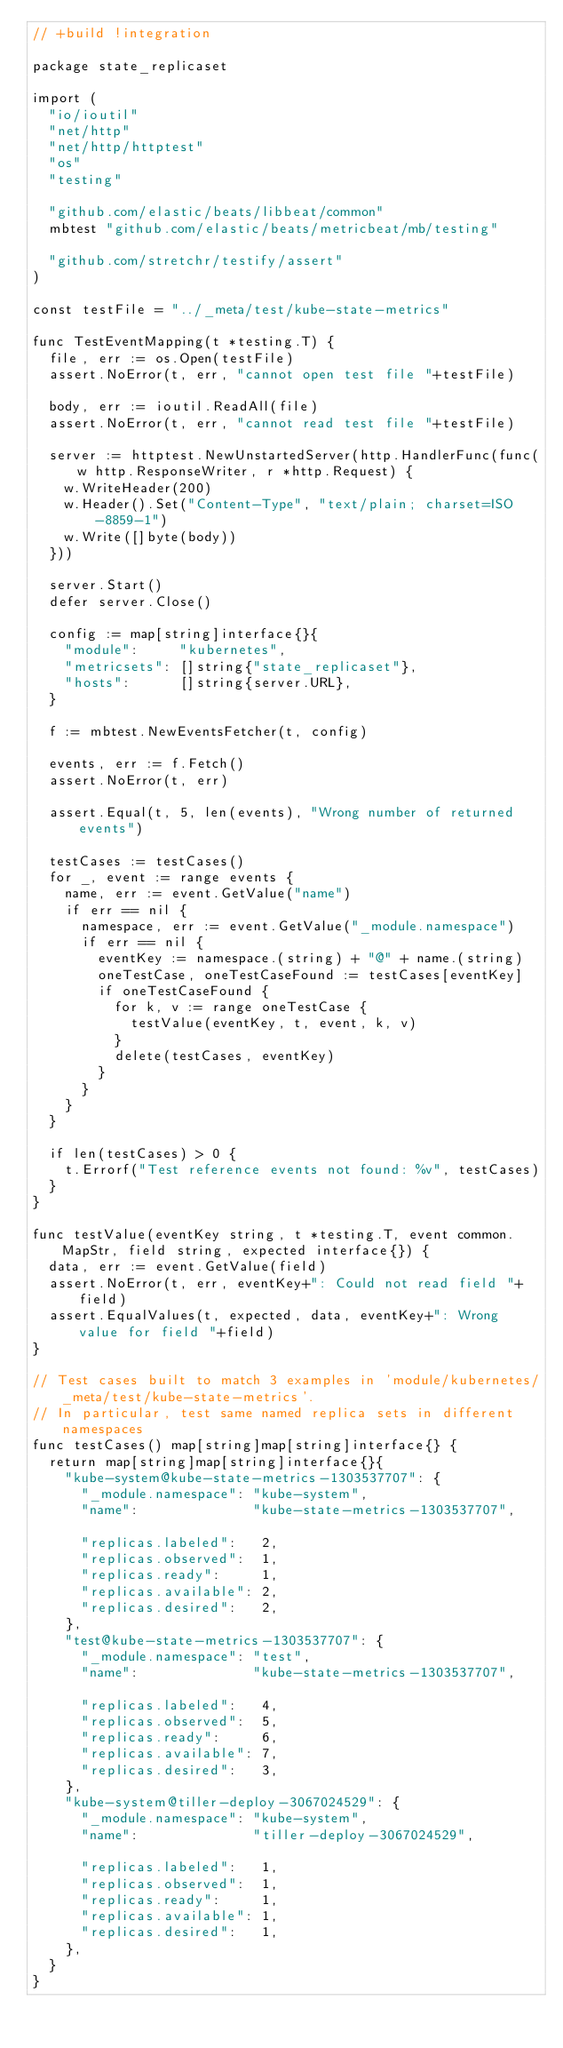Convert code to text. <code><loc_0><loc_0><loc_500><loc_500><_Go_>// +build !integration

package state_replicaset

import (
	"io/ioutil"
	"net/http"
	"net/http/httptest"
	"os"
	"testing"

	"github.com/elastic/beats/libbeat/common"
	mbtest "github.com/elastic/beats/metricbeat/mb/testing"

	"github.com/stretchr/testify/assert"
)

const testFile = "../_meta/test/kube-state-metrics"

func TestEventMapping(t *testing.T) {
	file, err := os.Open(testFile)
	assert.NoError(t, err, "cannot open test file "+testFile)

	body, err := ioutil.ReadAll(file)
	assert.NoError(t, err, "cannot read test file "+testFile)

	server := httptest.NewUnstartedServer(http.HandlerFunc(func(w http.ResponseWriter, r *http.Request) {
		w.WriteHeader(200)
		w.Header().Set("Content-Type", "text/plain; charset=ISO-8859-1")
		w.Write([]byte(body))
	}))

	server.Start()
	defer server.Close()

	config := map[string]interface{}{
		"module":     "kubernetes",
		"metricsets": []string{"state_replicaset"},
		"hosts":      []string{server.URL},
	}

	f := mbtest.NewEventsFetcher(t, config)

	events, err := f.Fetch()
	assert.NoError(t, err)

	assert.Equal(t, 5, len(events), "Wrong number of returned events")

	testCases := testCases()
	for _, event := range events {
		name, err := event.GetValue("name")
		if err == nil {
			namespace, err := event.GetValue("_module.namespace")
			if err == nil {
				eventKey := namespace.(string) + "@" + name.(string)
				oneTestCase, oneTestCaseFound := testCases[eventKey]
				if oneTestCaseFound {
					for k, v := range oneTestCase {
						testValue(eventKey, t, event, k, v)
					}
					delete(testCases, eventKey)
				}
			}
		}
	}

	if len(testCases) > 0 {
		t.Errorf("Test reference events not found: %v", testCases)
	}
}

func testValue(eventKey string, t *testing.T, event common.MapStr, field string, expected interface{}) {
	data, err := event.GetValue(field)
	assert.NoError(t, err, eventKey+": Could not read field "+field)
	assert.EqualValues(t, expected, data, eventKey+": Wrong value for field "+field)
}

// Test cases built to match 3 examples in 'module/kubernetes/_meta/test/kube-state-metrics'.
// In particular, test same named replica sets in different namespaces
func testCases() map[string]map[string]interface{} {
	return map[string]map[string]interface{}{
		"kube-system@kube-state-metrics-1303537707": {
			"_module.namespace": "kube-system",
			"name":              "kube-state-metrics-1303537707",

			"replicas.labeled":   2,
			"replicas.observed":  1,
			"replicas.ready":     1,
			"replicas.available": 2,
			"replicas.desired":   2,
		},
		"test@kube-state-metrics-1303537707": {
			"_module.namespace": "test",
			"name":              "kube-state-metrics-1303537707",

			"replicas.labeled":   4,
			"replicas.observed":  5,
			"replicas.ready":     6,
			"replicas.available": 7,
			"replicas.desired":   3,
		},
		"kube-system@tiller-deploy-3067024529": {
			"_module.namespace": "kube-system",
			"name":              "tiller-deploy-3067024529",

			"replicas.labeled":   1,
			"replicas.observed":  1,
			"replicas.ready":     1,
			"replicas.available": 1,
			"replicas.desired":   1,
		},
	}
}
</code> 